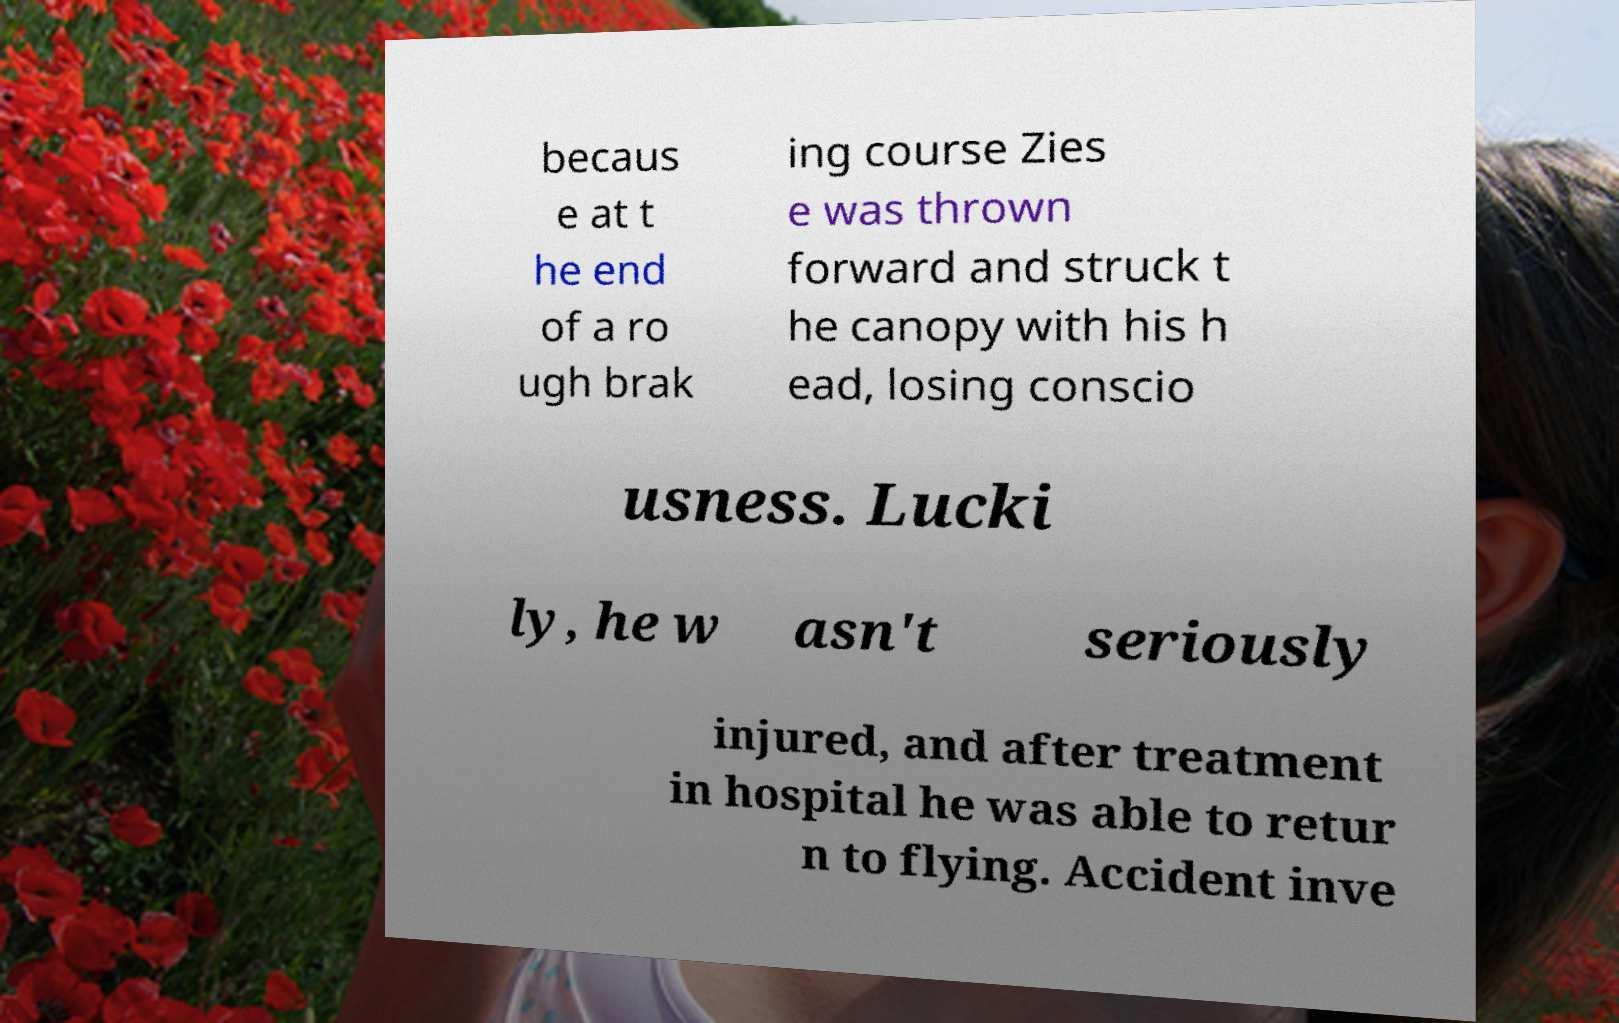For documentation purposes, I need the text within this image transcribed. Could you provide that? becaus e at t he end of a ro ugh brak ing course Zies e was thrown forward and struck t he canopy with his h ead, losing conscio usness. Lucki ly, he w asn't seriously injured, and after treatment in hospital he was able to retur n to flying. Accident inve 